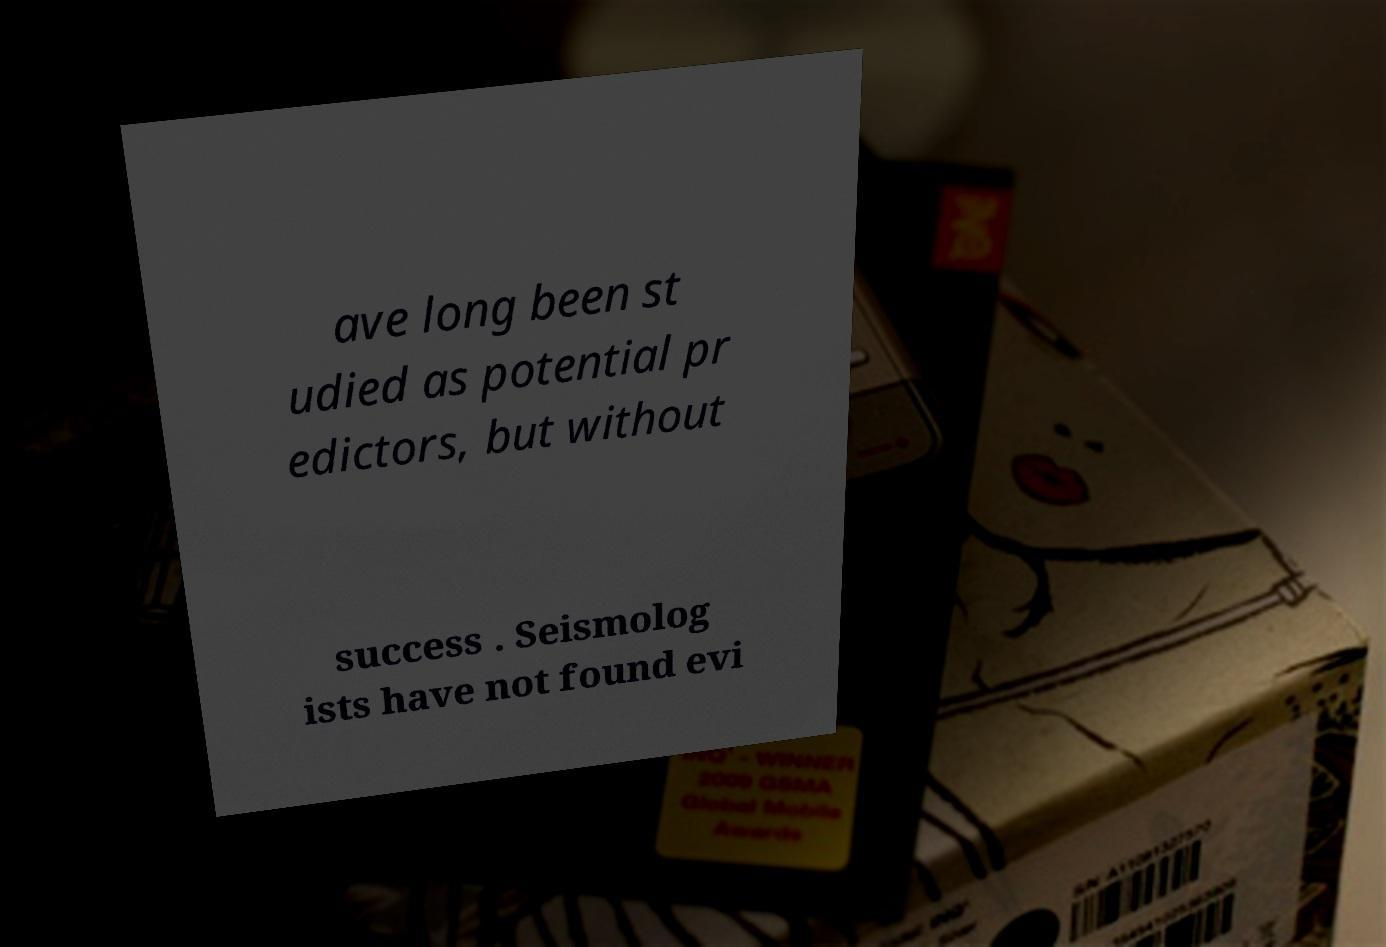Can you read and provide the text displayed in the image?This photo seems to have some interesting text. Can you extract and type it out for me? ave long been st udied as potential pr edictors, but without success . Seismolog ists have not found evi 